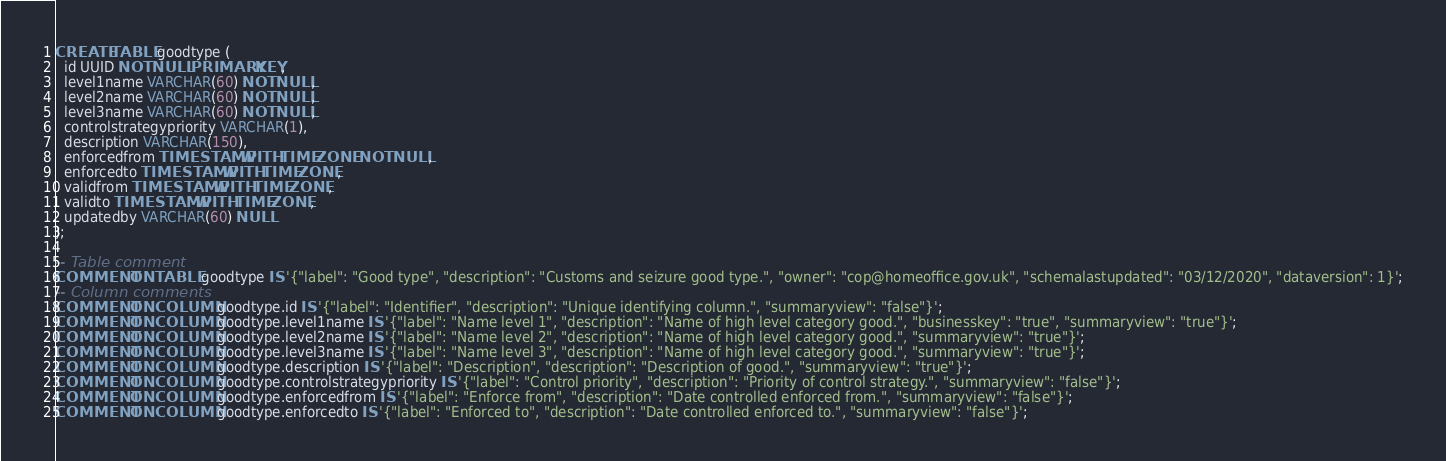<code> <loc_0><loc_0><loc_500><loc_500><_SQL_>CREATE TABLE goodtype (
  id UUID NOT NULL PRIMARY KEY,
  level1name VARCHAR(60) NOT NULL,
  level2name VARCHAR(60) NOT NULL,
  level3name VARCHAR(60) NOT NULL,
  controlstrategypriority VARCHAR(1),
  description VARCHAR(150),
  enforcedfrom TIMESTAMP WITH TIME ZONE NOT NULL,
  enforcedto TIMESTAMP WITH TIME ZONE,
  validfrom TIMESTAMP WITH TIME ZONE,
  validto TIMESTAMP WITH TIME ZONE,
  updatedby VARCHAR(60) NULL
);

-- Table comment
COMMENT ON TABLE goodtype IS '{"label": "Good type", "description": "Customs and seizure good type.", "owner": "cop@homeoffice.gov.uk", "schemalastupdated": "03/12/2020", "dataversion": 1}';
-- Column comments
COMMENT ON COLUMN goodtype.id IS '{"label": "Identifier", "description": "Unique identifying column.", "summaryview": "false"}';
COMMENT ON COLUMN goodtype.level1name IS '{"label": "Name level 1", "description": "Name of high level category good.", "businesskey": "true", "summaryview": "true"}';
COMMENT ON COLUMN goodtype.level2name IS '{"label": "Name level 2", "description": "Name of high level category good.", "summaryview": "true"}';
COMMENT ON COLUMN goodtype.level3name IS '{"label": "Name level 3", "description": "Name of high level category good.", "summaryview": "true"}';
COMMENT ON COLUMN goodtype.description IS '{"label": "Description", "description": "Description of good.", "summaryview": "true"}';
COMMENT ON COLUMN goodtype.controlstrategypriority IS '{"label": "Control priority", "description": "Priority of control strategy.", "summaryview": "false"}';
COMMENT ON COLUMN goodtype.enforcedfrom IS '{"label": "Enforce from", "description": "Date controlled enforced from.", "summaryview": "false"}';
COMMENT ON COLUMN goodtype.enforcedto IS '{"label": "Enforced to", "description": "Date controlled enforced to.", "summaryview": "false"}';</code> 